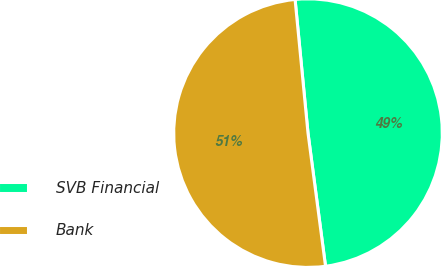<chart> <loc_0><loc_0><loc_500><loc_500><pie_chart><fcel>SVB Financial<fcel>Bank<nl><fcel>49.45%<fcel>50.55%<nl></chart> 